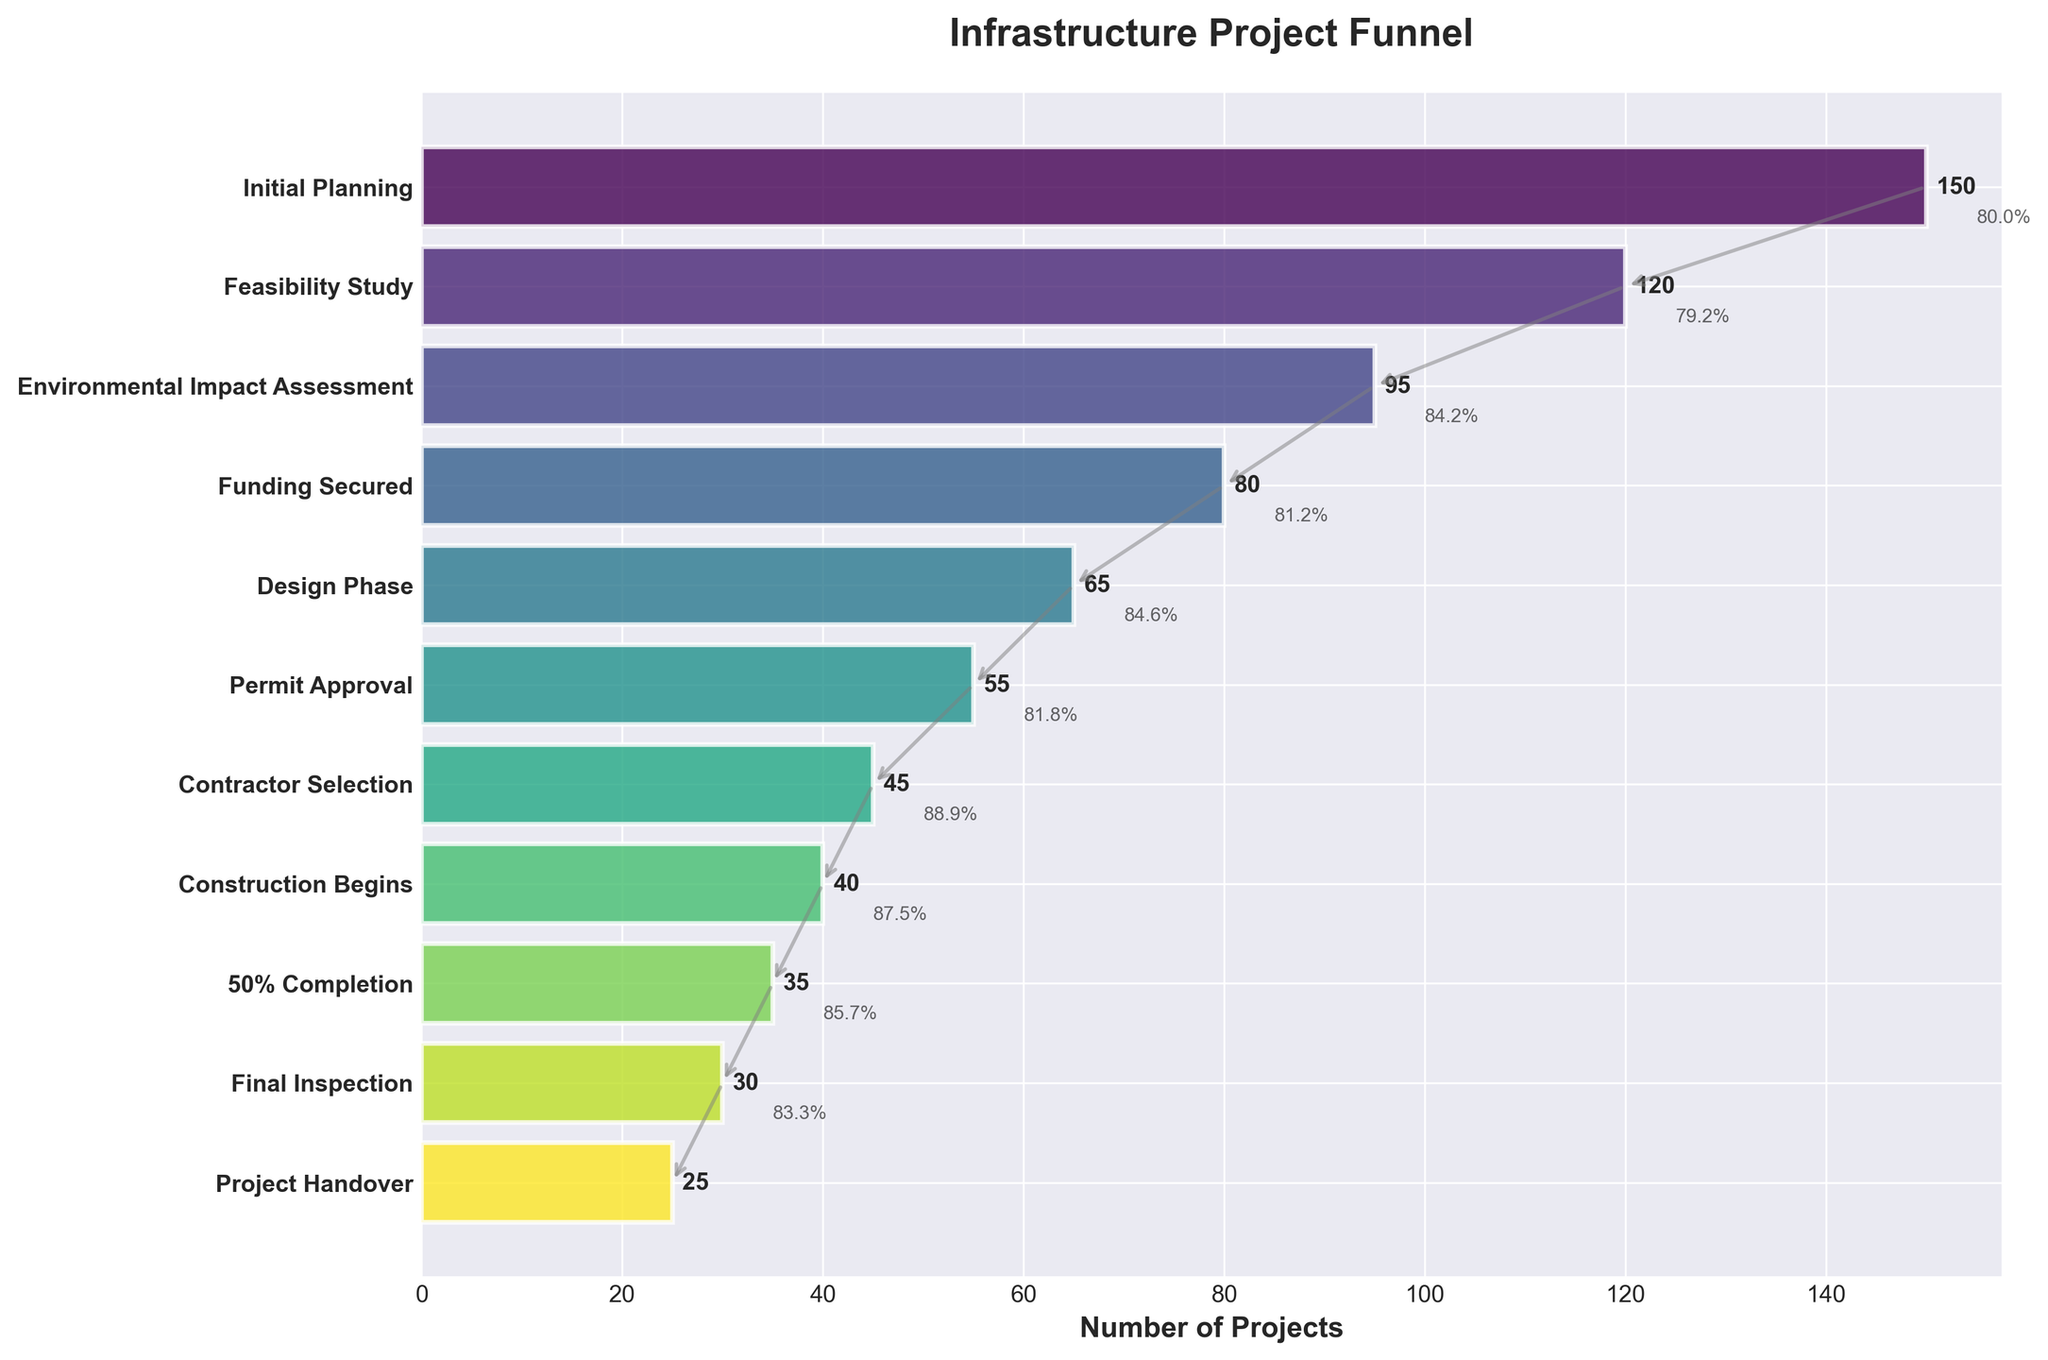What's the title of the figure? The title of the figure is usually located at the top of the chart. In this case, the title is "Infrastructure Project Funnel."
Answer: Infrastructure Project Funnel How many projects reached the Design Phase? To find this, you look at the bar corresponding to the Design Phase. It is labeled with the number of projects.
Answer: 65 What phase has the highest attrition rate? Compare the percentage drops between consecutive phases and identify the largest percentage drop. The drop from Initial Planning (150) to Feasibility Study (120) is (150-120)/150 * 100 ≈ 20%, which is the largest drop.
Answer: Initial Planning to Feasibility Study Which phase immediately follows Contractor Selection? Look at the order of the phases; the phase following Contractor Selection is Construction Begins.
Answer: Construction Begins What is the total number of projects that completed Final Inspection? Check the bar labeled Final Inspection, which shows the number of projects that reached this phase.
Answer: 30 How many more projects had Permit Approval compared to those completing Construction Begins? Subtract the number of projects in Construction Begins (40) from Permit Approval (55): 55 - 40 = 15.
Answer: 15 Which step shows a 50% completion status? Look for the phase labeled "50% Completion." This indicates the projects that have reached 50% of their construction phase.
Answer: 50% Completion What is the percentage of projects that went from Final Inspection to Project Handover? Calculate the ratio of Project Handover projects (25) to Final Inspection projects (30) and multiply by 100: (25/30) * 100 ≈ 83.3%.
Answer: 83.3% How many projects did not proceed from Environmental Impact Assessment to Funding Secured? Subtract the number of projects in Funding Secured (80) from those in Environmental Impact Assessment (95): 95 - 80 = 15.
Answer: 15 What's the average number of projects across all phases? Sum all the projects and divide by the number of phases: (150 + 120 + 95 + 80 + 65 + 55 + 45 + 40 + 35 + 30 + 25) / 11 ≈ 66.8.
Answer: 66.8 